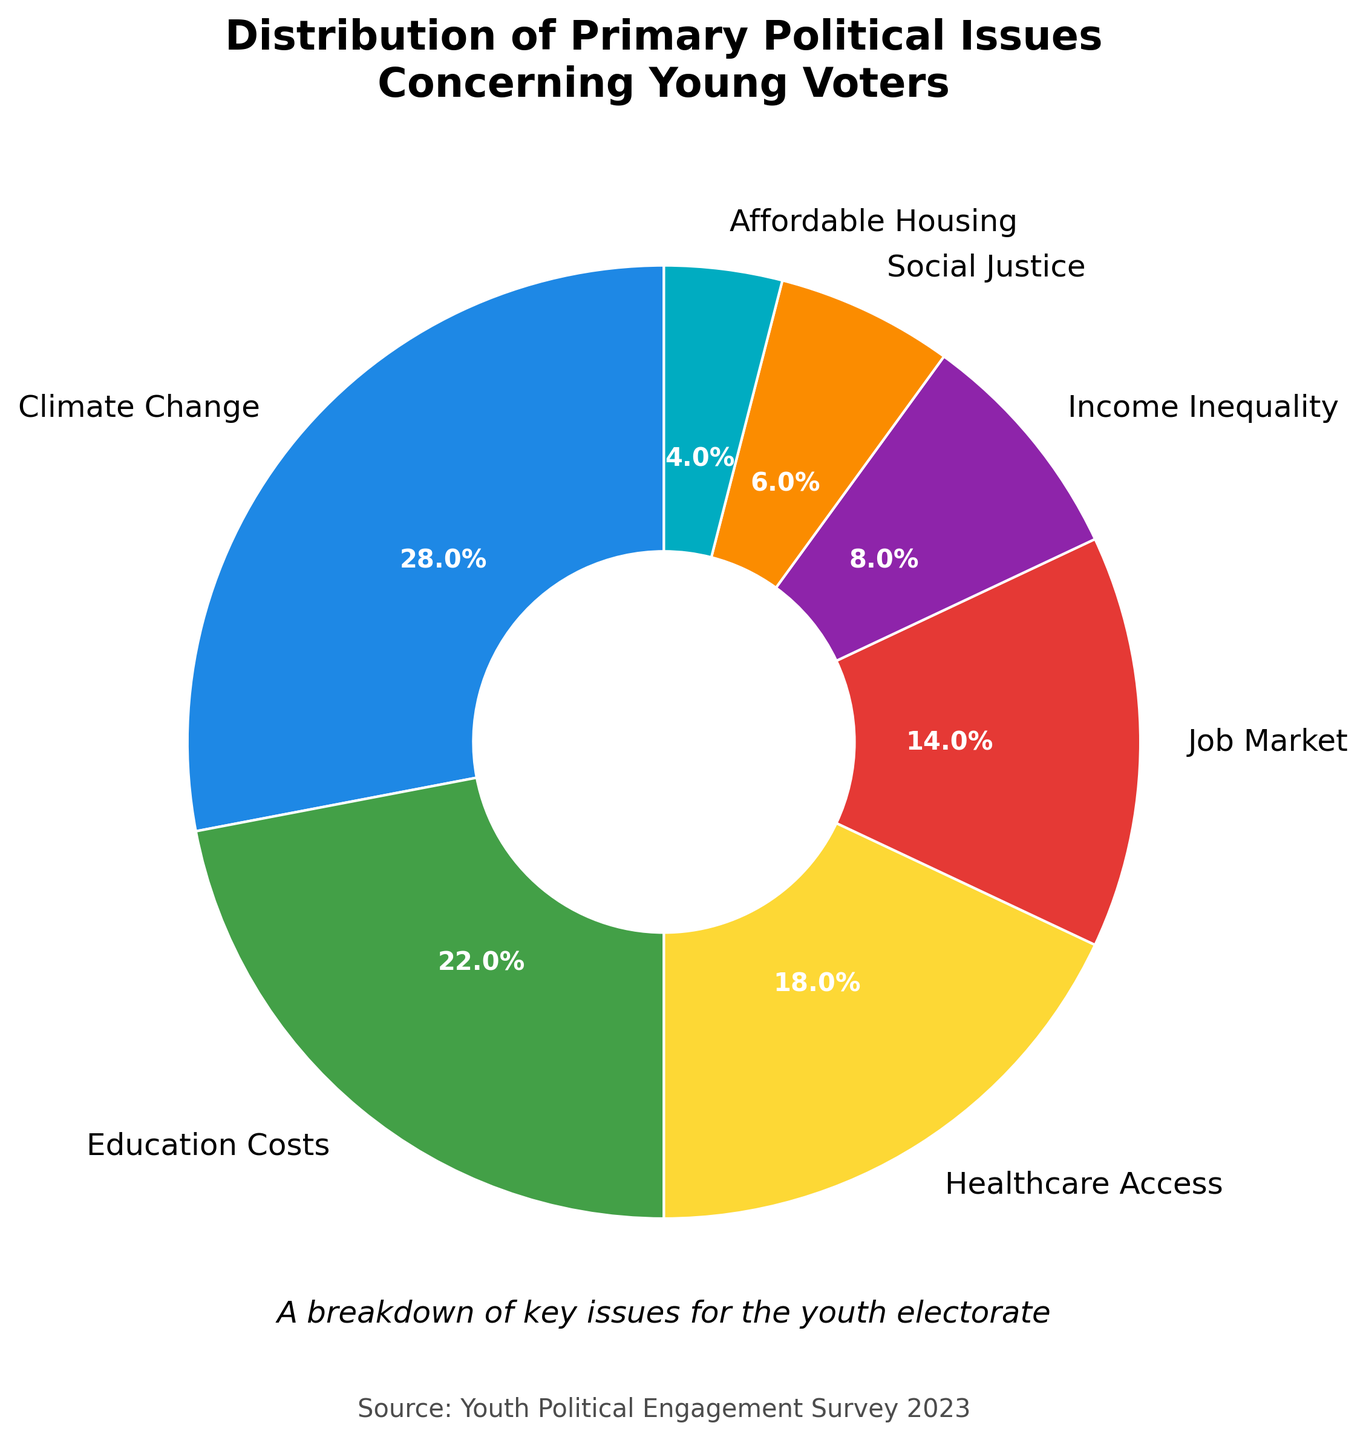What political issue concerns the highest percentage of young voters? First, identify the section of the pie chart with the largest percentage. The largest section is "Climate Change" with 28%.
Answer: Climate Change What political issue concerns the lowest percentage of young voters? Identify the section of the pie chart with the smallest percentage. The smallest section is "Affordable Housing" with 4%.
Answer: Affordable Housing Which issue concerns more young voters, Education Costs or Social Justice? Find the percentages of the sections labeled "Education Costs" (22%) and "Social Justice" (6%) and compare them. 22% is greater than 6%.
Answer: Education Costs How much more concern does Climate Change receive compared to Income Inequality? Determine the percentages for "Climate Change" (28%) and "Income Inequality" (8%) and subtract the latter from the former: 28% - 8% = 20%.
Answer: 20% What percentage of young voters are concerned with Healthcare Access and Income Inequality combined? Add the percentages for "Healthcare Access" (18%) and "Income Inequality" (8%): 18% + 8% = 26%.
Answer: 26% Is the sum of the proportions of young voters concerned with Social Justice and Affordable Housing greater or less than the proportion concerned with Climate Change? Add the percentages for "Social Justice" (6%) and "Affordable Housing" (4%): 6% + 4% = 10%, and compare this to "Climate Change" (28%). 10% is less than 28%.
Answer: Less Which is of more concern among young voters, the Job Market or Education Costs? Compare the percentages for "Job Market" (14%) and "Education Costs" (22%). 22% is greater than 14%.
Answer: Education Costs How many times greater is the concern for Climate Change compared to Affordable Housing? Divide the percentage for "Climate Change" (28%) by the percentage for "Affordable Housing" (4%): 28% / 4% = 7 times.
Answer: 7 times If a section of the pie chart is green, what issue does it represent? Identify the section colored green (use visual cues) and match it with its label. The green section corresponds to "Education Costs".
Answer: Education Costs 